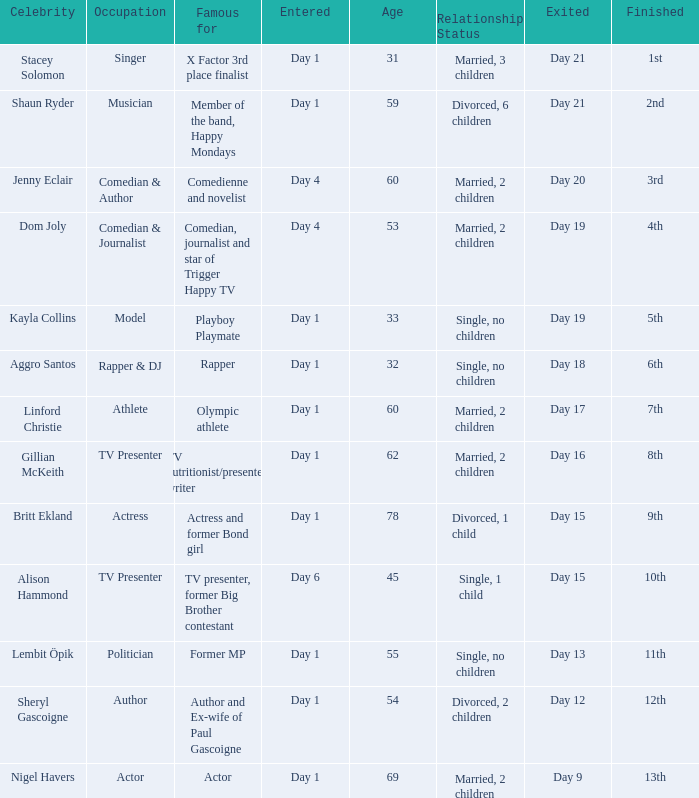Which celebrity was famous for being a rapper? Aggro Santos. 